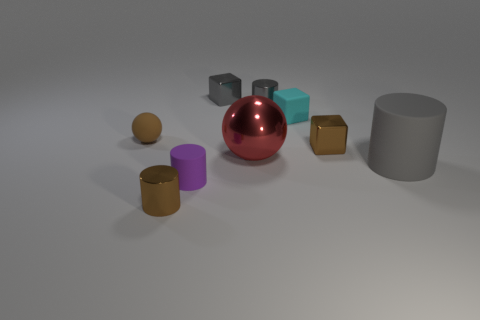Subtract all small brown cylinders. How many cylinders are left? 3 Add 1 tiny yellow cylinders. How many objects exist? 10 Subtract all brown balls. How many balls are left? 1 Subtract all cylinders. How many objects are left? 5 Subtract all purple balls. How many gray cylinders are left? 2 Subtract 0 yellow spheres. How many objects are left? 9 Subtract 2 balls. How many balls are left? 0 Subtract all red blocks. Subtract all cyan cylinders. How many blocks are left? 3 Subtract all red rubber balls. Subtract all big matte cylinders. How many objects are left? 8 Add 9 brown matte things. How many brown matte things are left? 10 